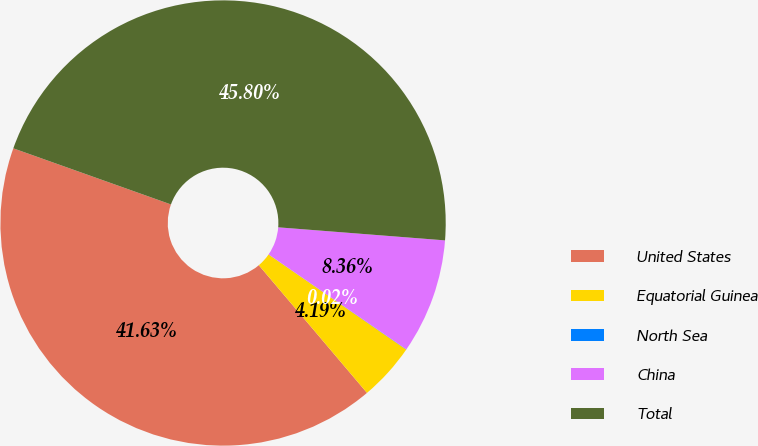Convert chart. <chart><loc_0><loc_0><loc_500><loc_500><pie_chart><fcel>United States<fcel>Equatorial Guinea<fcel>North Sea<fcel>China<fcel>Total<nl><fcel>41.63%<fcel>4.19%<fcel>0.02%<fcel>8.36%<fcel>45.8%<nl></chart> 